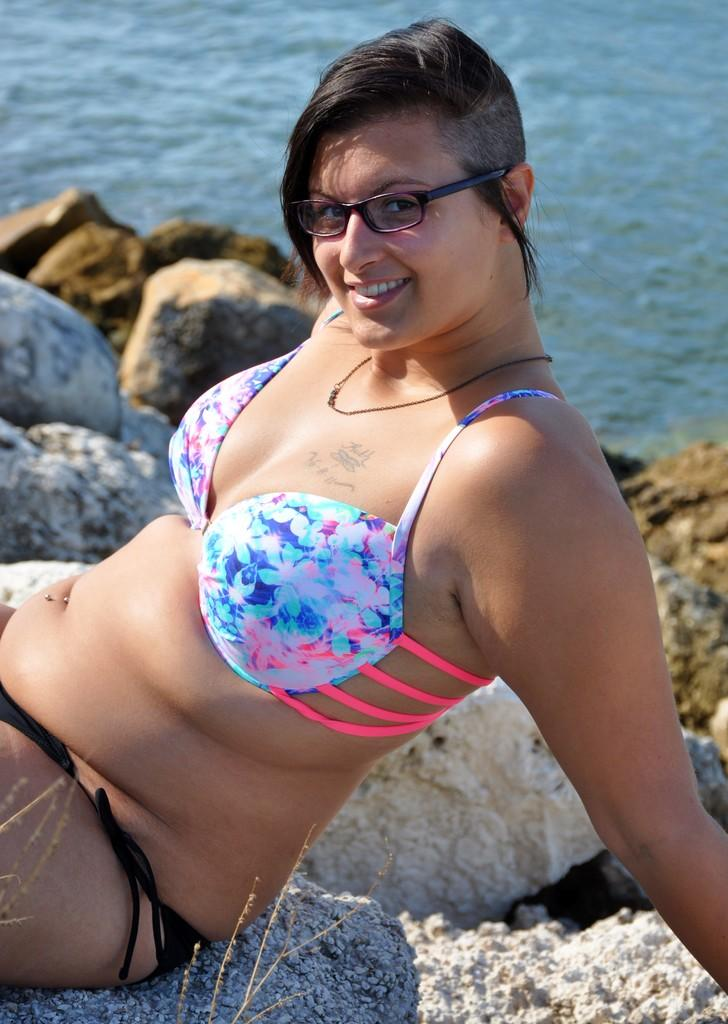Who is the main subject in the image? There is a lady in the image. What is the lady doing in the image? The lady is sitting on a rock. What can be seen in the background of the image? There is water and rocks visible in the background of the image. What type of ink is the lady using to write on the rock? There is no ink or writing present in the image; the lady is simply sitting on the rock. 